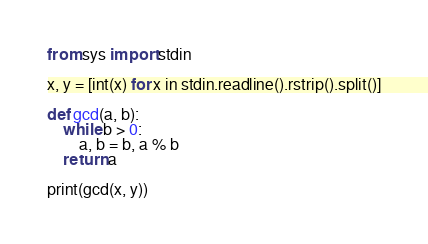Convert code to text. <code><loc_0><loc_0><loc_500><loc_500><_Python_>from sys import stdin
 
x, y = [int(x) for x in stdin.readline().rstrip().split()]
 
def gcd(a, b):
    while b > 0:
        a, b = b, a % b
    return a
 
print(gcd(x, y))
</code> 